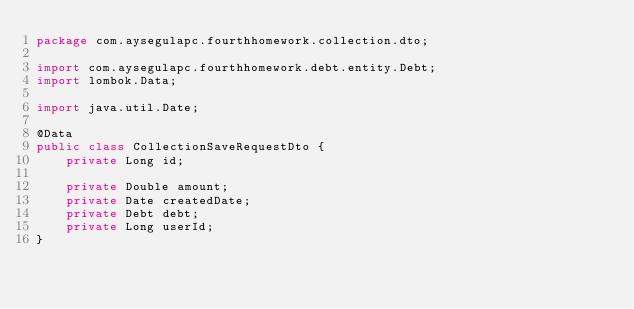Convert code to text. <code><loc_0><loc_0><loc_500><loc_500><_Java_>package com.aysegulapc.fourthhomework.collection.dto;

import com.aysegulapc.fourthhomework.debt.entity.Debt;
import lombok.Data;

import java.util.Date;

@Data
public class CollectionSaveRequestDto {
    private Long id;

    private Double amount;
    private Date createdDate;
    private Debt debt;
    private Long userId;
}
</code> 